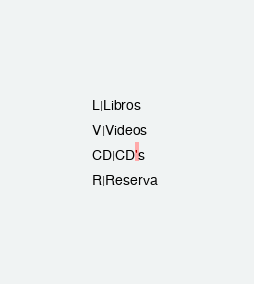Convert code to text. <code><loc_0><loc_0><loc_500><loc_500><_SQL_>L|Libros
V|Videos
CD|CD's
R|Reserva 
</code> 